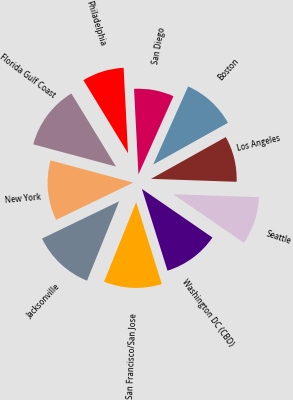Convert chart to OTSL. <chart><loc_0><loc_0><loc_500><loc_500><pie_chart><fcel>Florida Gulf Coast<fcel>New York<fcel>Jacksonville<fcel>San Francisco/San Jose<fcel>Washington DC (CBD)<fcel>Seattle<fcel>Los Angeles<fcel>Boston<fcel>San Diego<fcel>Philadelphia<nl><fcel>12.1%<fcel>11.34%<fcel>11.72%<fcel>10.95%<fcel>10.57%<fcel>9.05%<fcel>8.66%<fcel>10.19%<fcel>7.52%<fcel>7.9%<nl></chart> 